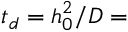<formula> <loc_0><loc_0><loc_500><loc_500>t _ { d } = h _ { 0 } ^ { 2 } / D =</formula> 